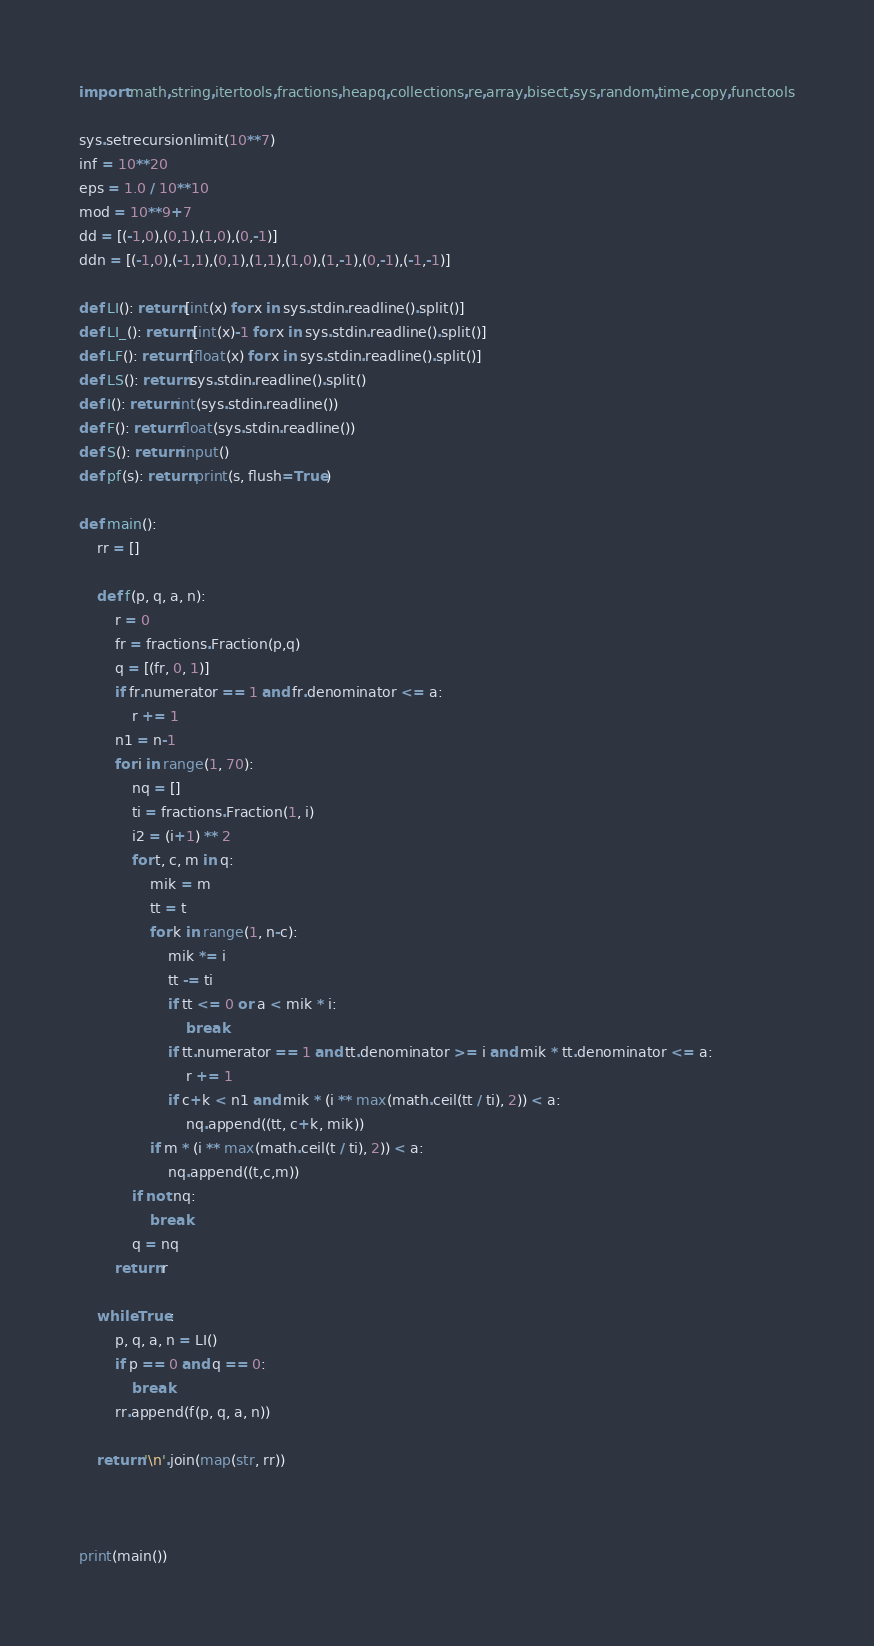<code> <loc_0><loc_0><loc_500><loc_500><_Python_>import math,string,itertools,fractions,heapq,collections,re,array,bisect,sys,random,time,copy,functools

sys.setrecursionlimit(10**7)
inf = 10**20
eps = 1.0 / 10**10
mod = 10**9+7
dd = [(-1,0),(0,1),(1,0),(0,-1)]
ddn = [(-1,0),(-1,1),(0,1),(1,1),(1,0),(1,-1),(0,-1),(-1,-1)]

def LI(): return [int(x) for x in sys.stdin.readline().split()]
def LI_(): return [int(x)-1 for x in sys.stdin.readline().split()]
def LF(): return [float(x) for x in sys.stdin.readline().split()]
def LS(): return sys.stdin.readline().split()
def I(): return int(sys.stdin.readline())
def F(): return float(sys.stdin.readline())
def S(): return input()
def pf(s): return print(s, flush=True)

def main():
    rr = []

    def f(p, q, a, n):
        r = 0
        fr = fractions.Fraction(p,q)
        q = [(fr, 0, 1)]
        if fr.numerator == 1 and fr.denominator <= a:
            r += 1
        n1 = n-1
        for i in range(1, 70):
            nq = []
            ti = fractions.Fraction(1, i)
            i2 = (i+1) ** 2
            for t, c, m in q:
                mik = m
                tt = t
                for k in range(1, n-c):
                    mik *= i
                    tt -= ti
                    if tt <= 0 or a < mik * i:
                        break
                    if tt.numerator == 1 and tt.denominator >= i and mik * tt.denominator <= a:
                        r += 1
                    if c+k < n1 and mik * (i ** max(math.ceil(tt / ti), 2)) < a:
                        nq.append((tt, c+k, mik))
                if m * (i ** max(math.ceil(t / ti), 2)) < a:
                    nq.append((t,c,m))
            if not nq:
                break
            q = nq
        return r

    while True:
        p, q, a, n = LI()
        if p == 0 and q == 0:
            break
        rr.append(f(p, q, a, n))

    return '\n'.join(map(str, rr))



print(main())

</code> 